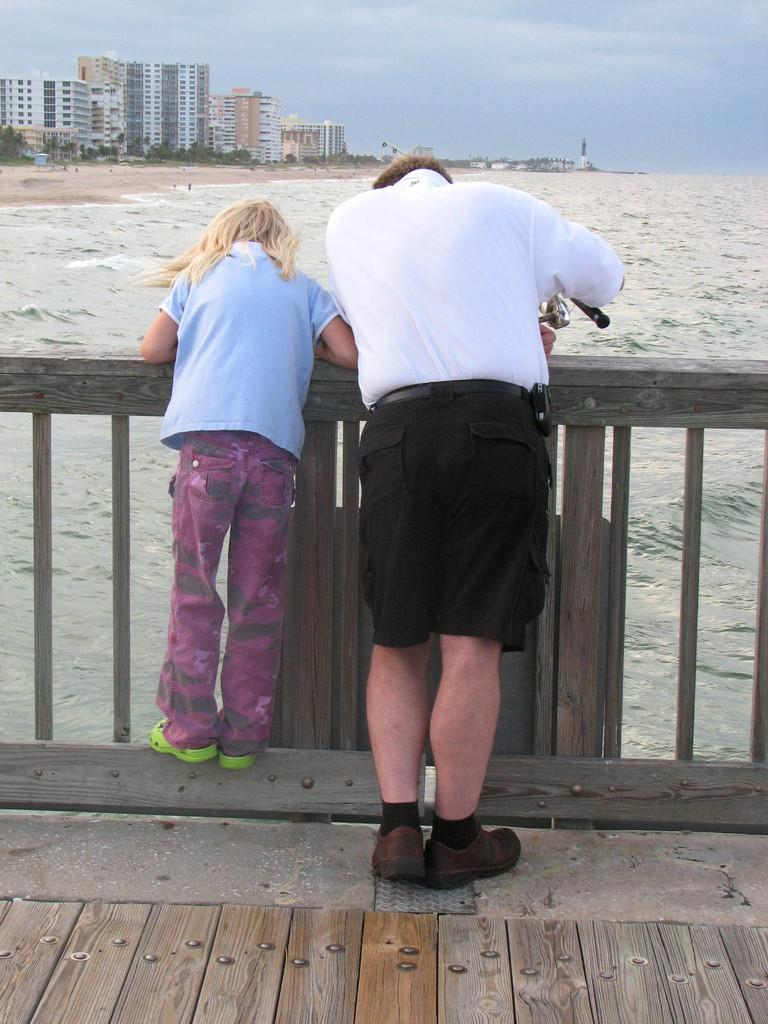Who are the people in the image? There is a man and a girl in the image. What are the man and the girl doing in the image? Both the man and the girl are standing in the image. Where are they standing? They are standing on a wooden path. What is in front of them? There is a railing in front of them. What can be seen in the distance? The sea is visible in the image, along with trees, buildings, and the sky in the background. Can you see the kitten's tail in the image? There is no kitten present in the image, so its tail cannot be seen. 